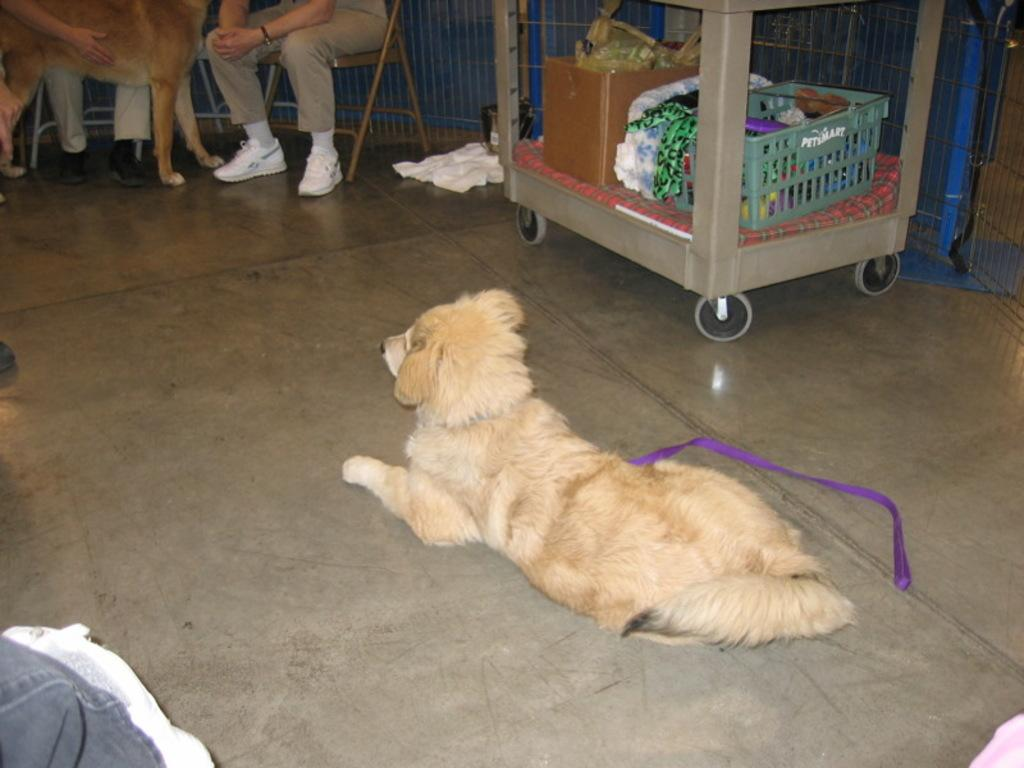What type of animal can be seen in the image? There is a dog in the image. What are the people in the image doing? The people are sitting on chairs in the image. What is inside the container in the image? The facts do not specify what objects are inside the container. What type of surface is visible in the image? There is a floor visible in the image. How much payment is required to obtain the dog's desire in the image? There is no mention of payment or the dog's desire in the image. 